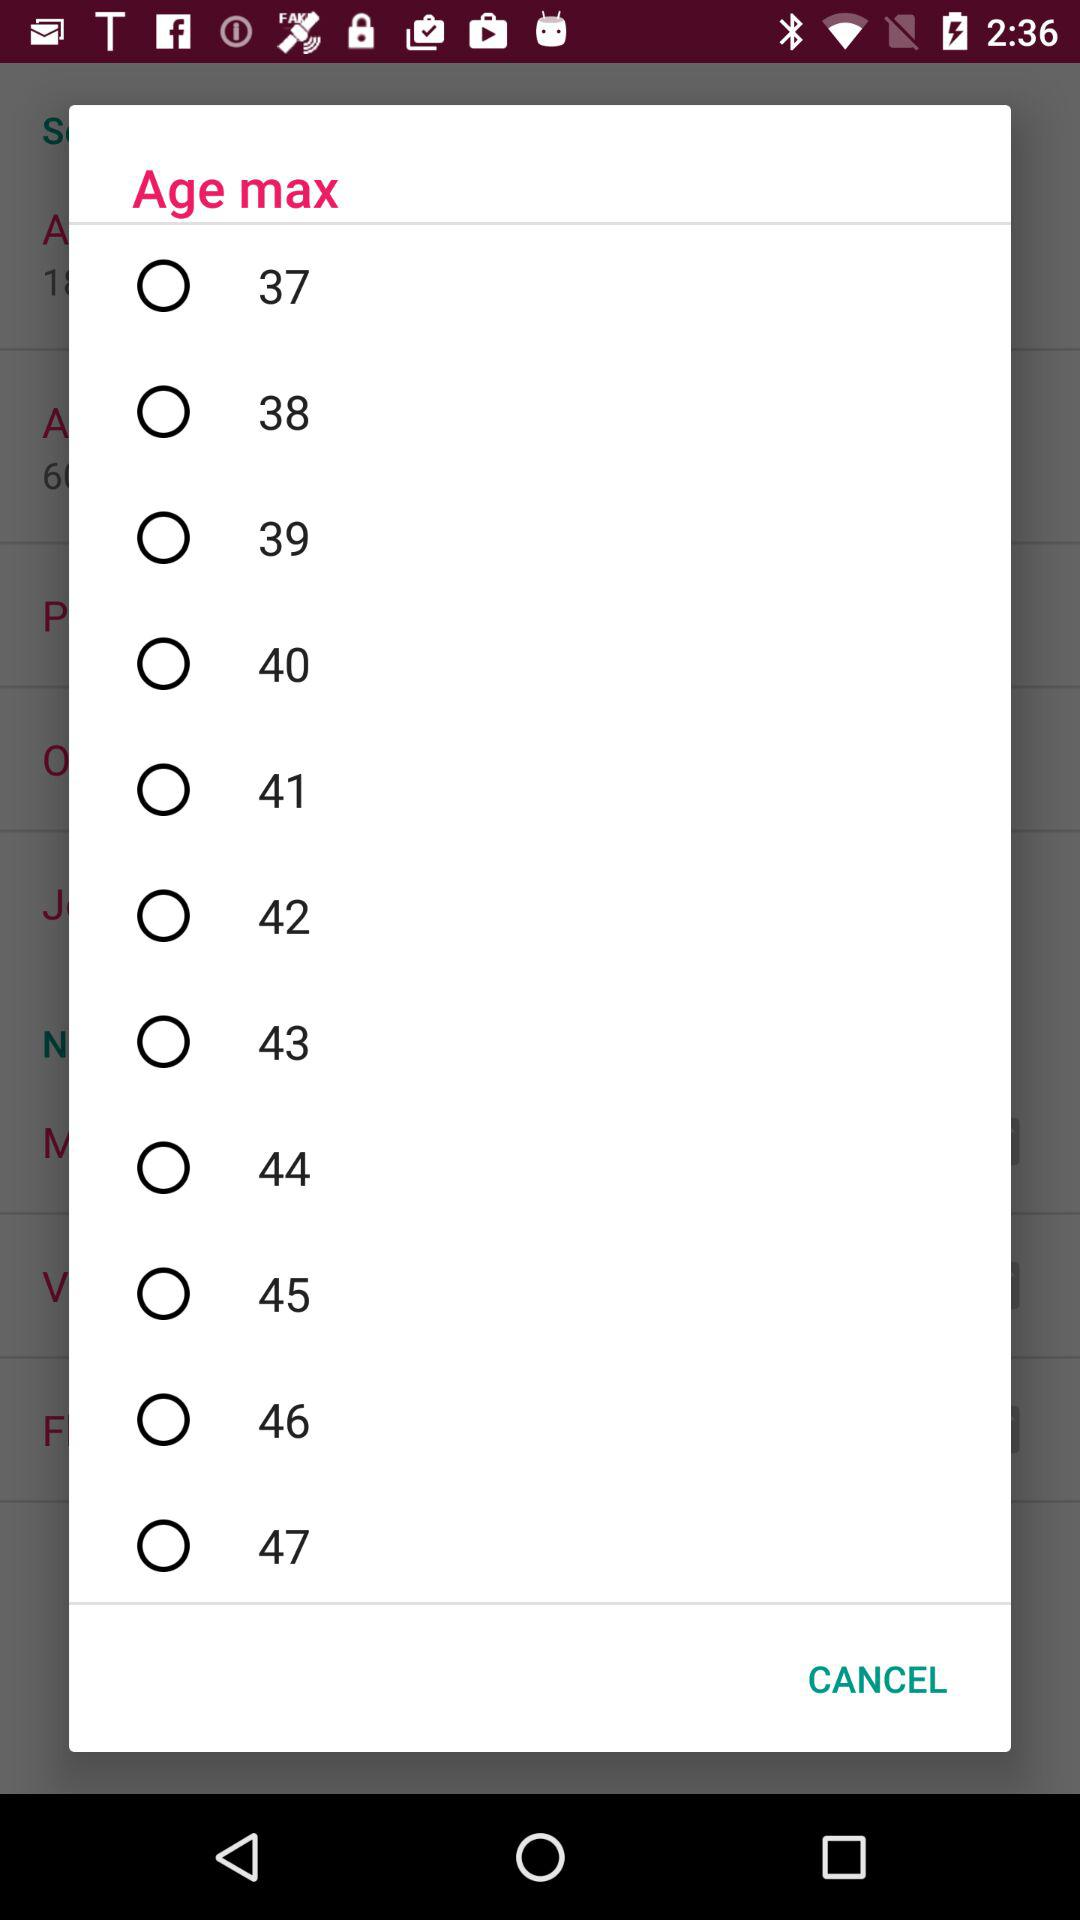What is the minimum age range?
When the provided information is insufficient, respond with <no answer>. <no answer> 